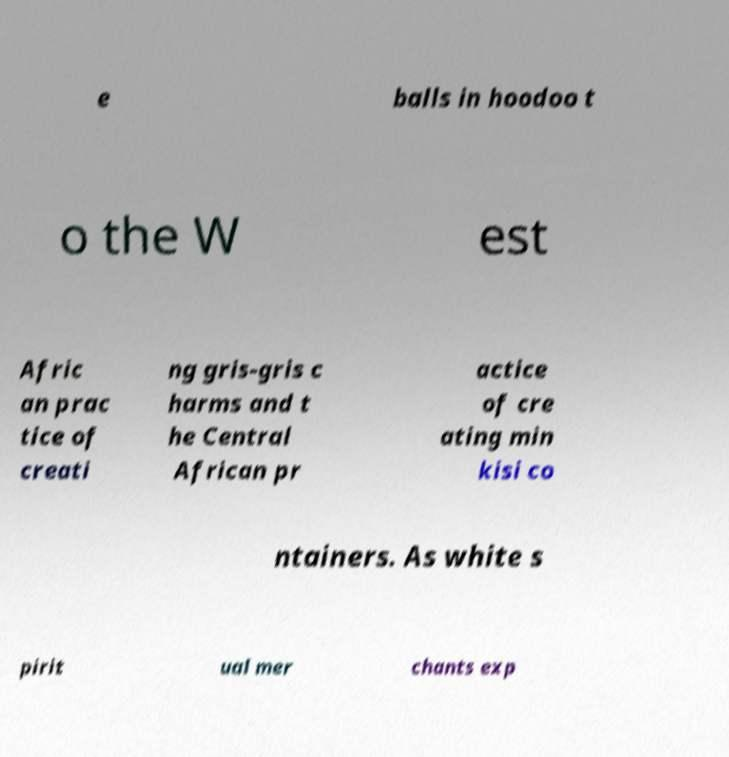Please identify and transcribe the text found in this image. e balls in hoodoo t o the W est Afric an prac tice of creati ng gris-gris c harms and t he Central African pr actice of cre ating min kisi co ntainers. As white s pirit ual mer chants exp 